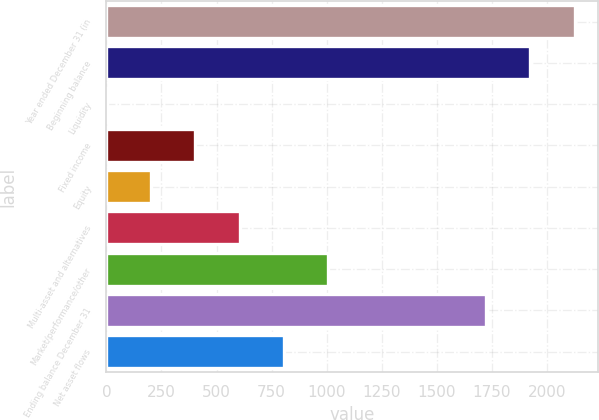Convert chart. <chart><loc_0><loc_0><loc_500><loc_500><bar_chart><fcel>Year ended December 31 (in<fcel>Beginning balance<fcel>Liquidity<fcel>Fixed income<fcel>Equity<fcel>Multi-asset and alternatives<fcel>Market/performance/other<fcel>Ending balance December 31<fcel>Net asset flows<nl><fcel>2125.8<fcel>1924.4<fcel>1<fcel>403.8<fcel>202.4<fcel>605.2<fcel>1008<fcel>1723<fcel>806.6<nl></chart> 